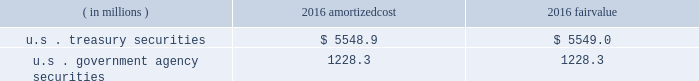Each clearing firm is required to deposit and maintain balances in the form of cash , u.s .
Government securities , certain foreign government securities , bank letters of credit or other approved investments to satisfy performance bond and guaranty fund requirements .
All non-cash deposits are marked-to-market and haircut on a daily basis .
Securities deposited by the clearing firms are not reflected in the consolidated financial statements and the clearing house does not earn any interest on these deposits .
These balances may fluctuate significantly over time due to investment choices available to clearing firms and changes in the amount of contributions required .
In addition , the rules and regulations of cbot require that collateral be provided for delivery of physical commodities , maintenance of capital requirements and deposits on pending arbitration matters .
To satisfy these requirements , clearing firms that have accounts that trade certain cbot products have deposited cash , u.s .
Treasury securities or letters of credit .
The clearing house marks-to-market open positions at least once a day ( twice a day for futures and options contracts ) , and require payment from clearing firms whose positions have lost value and make payments to clearing firms whose positions have gained value .
The clearing house has the capability to mark-to-market more frequently as market conditions warrant .
Under the extremely unlikely scenario of simultaneous default by every clearing firm who has open positions with unrealized losses , the maximum exposure related to positions other than credit default and interest rate swap contracts would be one half day of changes in fair value of all open positions , before considering the clearing houses 2019 ability to access defaulting clearing firms 2019 collateral deposits .
For cleared credit default swap and interest rate swap contracts , the maximum exposure related to cme 2019s guarantee would be one full day of changes in fair value of all open positions , before considering cme 2019s ability to access defaulting clearing firms 2019 collateral .
During 2017 , the clearing house transferred an average of approximately $ 2.4 billion a day through the clearing system for settlement from clearing firms whose positions had lost value to clearing firms whose positions had gained value .
The clearing house reduces the guarantee exposure through initial and maintenance performance bond requirements and mandatory guaranty fund contributions .
The company believes that the guarantee liability is immaterial and therefore has not recorded any liability at december 31 , 2017 .
At december 31 , 2016 , performance bond and guaranty fund contribution assets on the consolidated balance sheets included cash as well as u.s .
Treasury and u.s .
Government agency securities with maturity dates of 90 days or less .
The u.s .
Treasury and u.s .
Government agency securities were purchased by cme , at its discretion , using cash collateral .
The benefits , including interest earned , and risks of ownership accrue to cme .
Interest earned is included in investment income on the consolidated statements of income .
There were no u.s .
Treasury and u.s .
Government agency securities held at december 31 , 2017 .
The amortized cost and fair value of these securities at december 31 , 2016 were as follows : ( in millions ) amortized .
Cme has been designated as a systemically important financial market utility by the financial stability oversight council and maintains a cash account at the federal reserve bank of chicago .
At december 31 , 2017 and december 31 , 2016 , cme maintained $ 34.2 billion and $ 6.2 billion , respectively , within the cash account at the federal reserve bank of chicago .
Clearing firms , at their option , may instruct cme to deposit the cash held by cme into one of the ief programs .
The total principal in the ief programs was $ 1.1 billion at december 31 , 2017 and $ 6.8 billion at december 31 .
What was total amount of cash held by the federal reserve bank of chicago on behalf of the cme , including cash accounts and ief programs on december 31st , 2016? 
Computations: (6.2 + 6.8)
Answer: 13.0. 